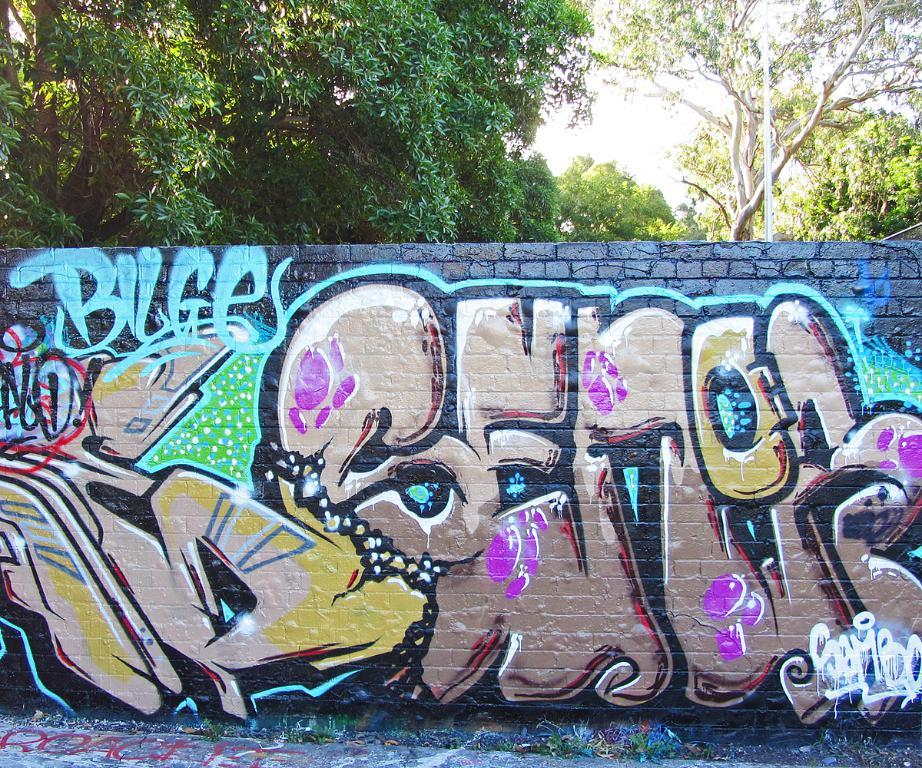What is located in the middle of the image? There is a painted wall in the middle of the image. What can be seen in the background of the image? There are trees in the background of the image. What type of trees are being sorted for tax purposes in the image? There are no trees being sorted or tax purposes depicted in the image; it only features a painted wall and trees in the background. 